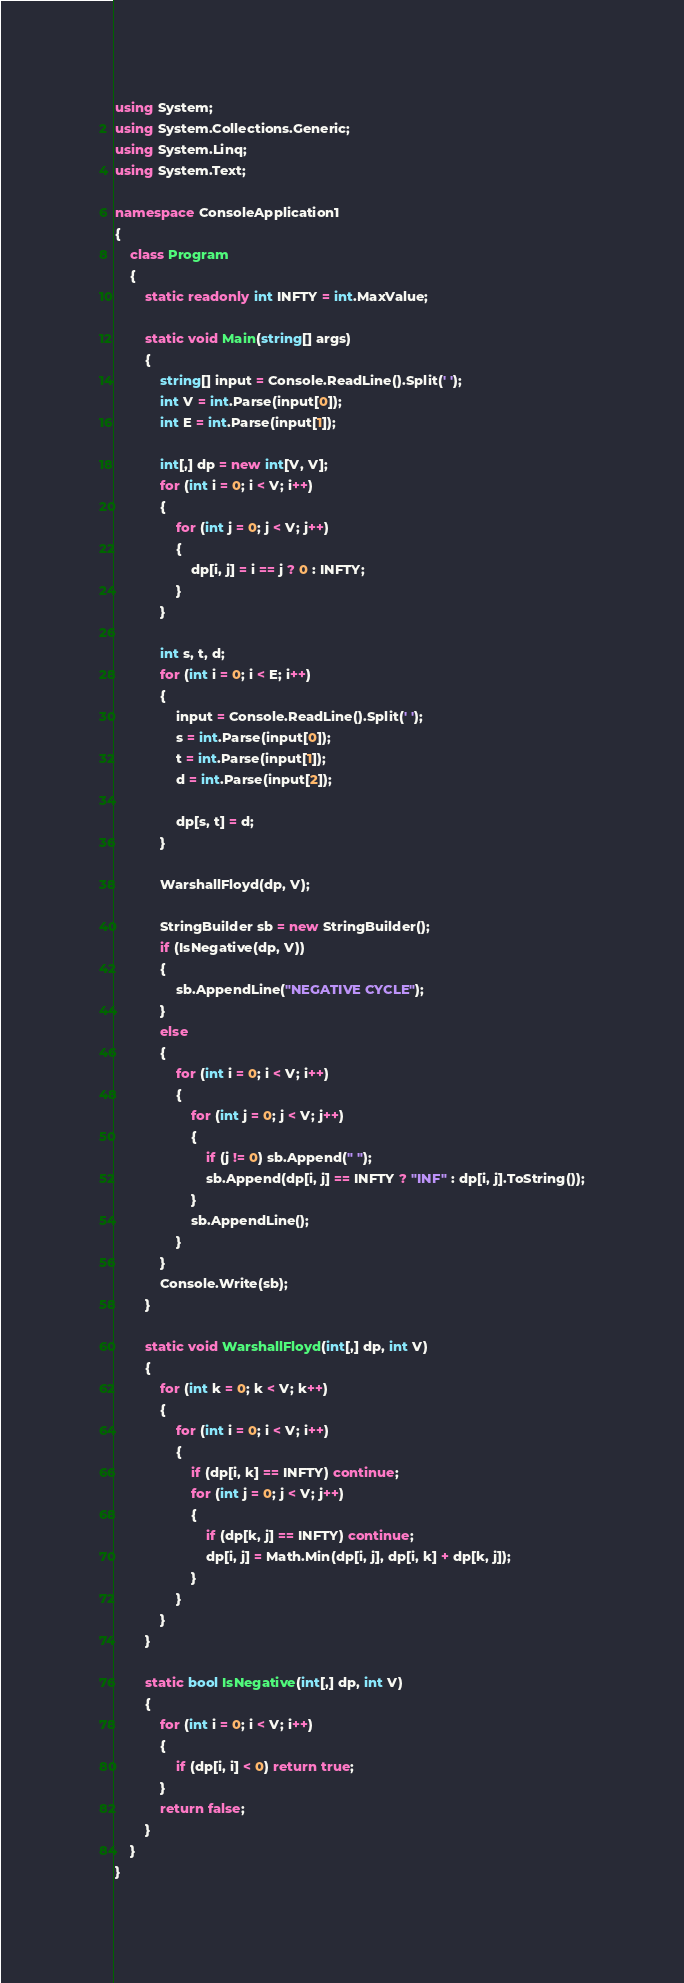<code> <loc_0><loc_0><loc_500><loc_500><_C#_>using System;
using System.Collections.Generic;
using System.Linq;
using System.Text;

namespace ConsoleApplication1
{
    class Program
    {
        static readonly int INFTY = int.MaxValue;

        static void Main(string[] args)
        {
            string[] input = Console.ReadLine().Split(' ');
            int V = int.Parse(input[0]);
            int E = int.Parse(input[1]);

            int[,] dp = new int[V, V];
            for (int i = 0; i < V; i++)
            {
                for (int j = 0; j < V; j++)
                {
                    dp[i, j] = i == j ? 0 : INFTY;
                }
            }

            int s, t, d;
            for (int i = 0; i < E; i++)
            {
                input = Console.ReadLine().Split(' ');
                s = int.Parse(input[0]);
                t = int.Parse(input[1]);
                d = int.Parse(input[2]);

                dp[s, t] = d;
            }

            WarshallFloyd(dp, V);

            StringBuilder sb = new StringBuilder();
            if (IsNegative(dp, V))
            {
                sb.AppendLine("NEGATIVE CYCLE");
            }
            else
            {
                for (int i = 0; i < V; i++)
                {
                    for (int j = 0; j < V; j++)
                    {
                        if (j != 0) sb.Append(" ");
                        sb.Append(dp[i, j] == INFTY ? "INF" : dp[i, j].ToString());
                    }
                    sb.AppendLine();
                }
            }
            Console.Write(sb);
        }

        static void WarshallFloyd(int[,] dp, int V)
        {
            for (int k = 0; k < V; k++)
            {
                for (int i = 0; i < V; i++)
                {
                    if (dp[i, k] == INFTY) continue;
                    for (int j = 0; j < V; j++)
                    {
                        if (dp[k, j] == INFTY) continue;
                        dp[i, j] = Math.Min(dp[i, j], dp[i, k] + dp[k, j]);
                    }
                }
            }
        }

        static bool IsNegative(int[,] dp, int V)
        {
            for (int i = 0; i < V; i++)
            {
                if (dp[i, i] < 0) return true;
            }
            return false;
        }
    }
}</code> 